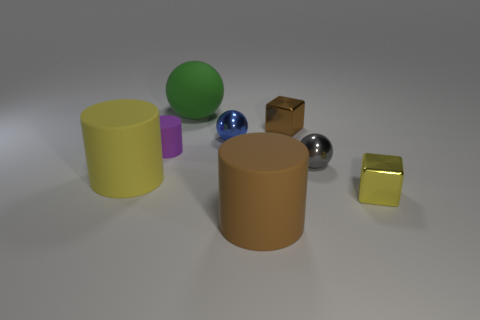Is the number of yellow shiny blocks that are behind the rubber sphere greater than the number of red metallic spheres?
Offer a terse response. No. Is the small blue ball made of the same material as the small purple cylinder?
Provide a short and direct response. No. How many other things are the same shape as the small brown object?
Provide a succinct answer. 1. Is there anything else that has the same material as the large brown object?
Provide a succinct answer. Yes. There is a matte cylinder that is behind the yellow thing left of the big matte cylinder right of the green thing; what is its color?
Make the answer very short. Purple. There is a small thing that is left of the big green thing; is it the same shape as the yellow matte thing?
Your answer should be compact. Yes. How many large cyan blocks are there?
Keep it short and to the point. 0. What number of gray things are the same size as the blue metallic sphere?
Give a very brief answer. 1. What material is the blue sphere?
Make the answer very short. Metal. There is a large rubber sphere; does it have the same color as the big matte cylinder that is to the right of the big yellow cylinder?
Your response must be concise. No. 